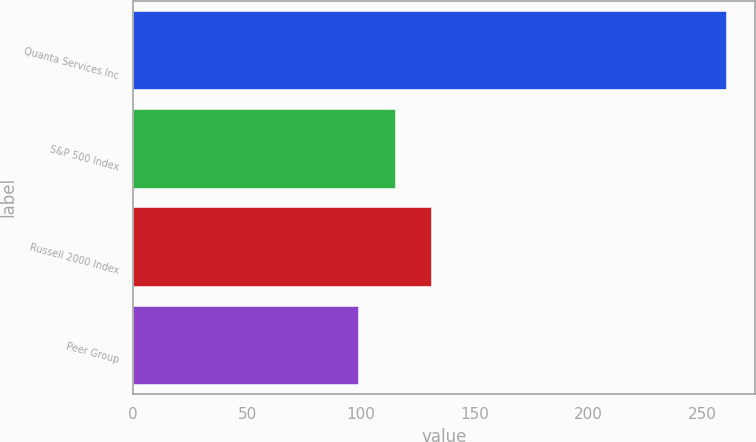Convert chart to OTSL. <chart><loc_0><loc_0><loc_500><loc_500><bar_chart><fcel>Quanta Services Inc<fcel>S&P 500 Index<fcel>Russell 2000 Index<fcel>Peer Group<nl><fcel>260.5<fcel>114.92<fcel>131.1<fcel>98.74<nl></chart> 